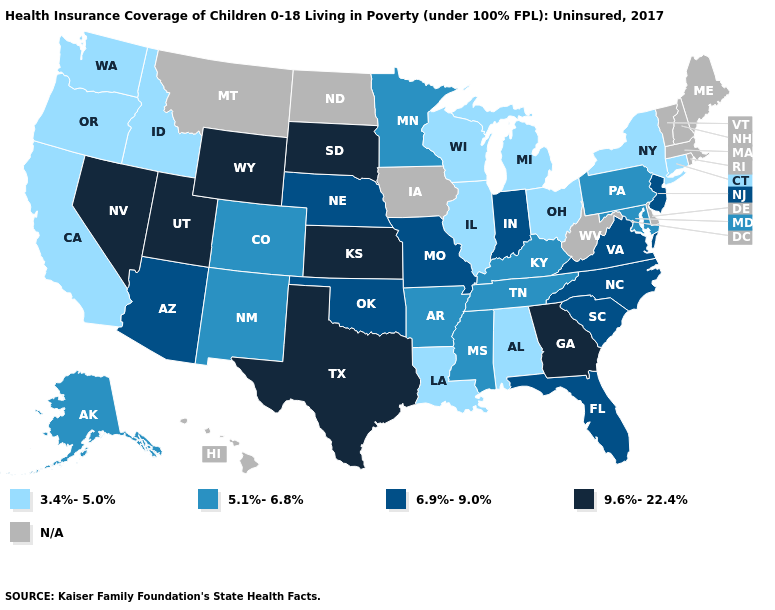What is the value of Connecticut?
Short answer required. 3.4%-5.0%. Which states have the lowest value in the MidWest?
Quick response, please. Illinois, Michigan, Ohio, Wisconsin. What is the value of Virginia?
Concise answer only. 6.9%-9.0%. Which states have the lowest value in the MidWest?
Short answer required. Illinois, Michigan, Ohio, Wisconsin. Does the first symbol in the legend represent the smallest category?
Keep it brief. Yes. Is the legend a continuous bar?
Answer briefly. No. What is the lowest value in states that border Vermont?
Keep it brief. 3.4%-5.0%. Name the states that have a value in the range 3.4%-5.0%?
Keep it brief. Alabama, California, Connecticut, Idaho, Illinois, Louisiana, Michigan, New York, Ohio, Oregon, Washington, Wisconsin. Name the states that have a value in the range 3.4%-5.0%?
Short answer required. Alabama, California, Connecticut, Idaho, Illinois, Louisiana, Michigan, New York, Ohio, Oregon, Washington, Wisconsin. Which states have the lowest value in the USA?
Answer briefly. Alabama, California, Connecticut, Idaho, Illinois, Louisiana, Michigan, New York, Ohio, Oregon, Washington, Wisconsin. Among the states that border California , which have the highest value?
Concise answer only. Nevada. What is the value of Missouri?
Concise answer only. 6.9%-9.0%. Is the legend a continuous bar?
Quick response, please. No. What is the highest value in the USA?
Keep it brief. 9.6%-22.4%. Name the states that have a value in the range 6.9%-9.0%?
Short answer required. Arizona, Florida, Indiana, Missouri, Nebraska, New Jersey, North Carolina, Oklahoma, South Carolina, Virginia. 